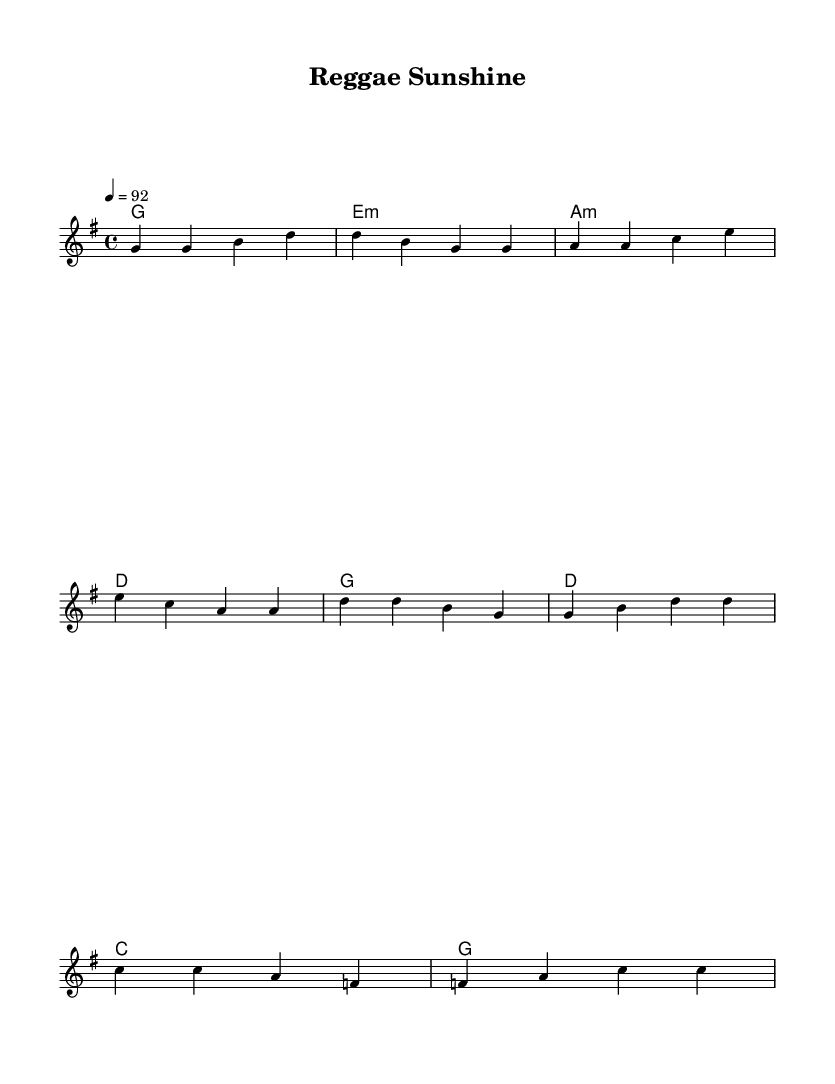What is the key signature of this music? The key signature is G major, which has one sharp (F#). This is determined by analyzing the key signature section in the sheet music, where it indicates the note functions.
Answer: G major What is the time signature of the piece? The time signature is 4/4, indicating there are four beats in each measure and the quarter note gets one beat. This can be found at the beginning of the score, near the clef and key signature.
Answer: 4/4 What is the tempo marking for this piece? The tempo marking is 92 beats per minute, given as "4 = 92" in the tempo indication. This tells us the speed at which to perform the music.
Answer: 92 How many measures are in the verse section? The verse section includes four measures, as counted from the notation in the music. Each set of bars indicates a measure, and there are four distinct groups for the verse.
Answer: 4 What chords are used in the chorus section? The chords for the chorus section are G, D, C, G. These are explicitly stated in the chord changes above the melody, following the progression laid out in the music.
Answer: G, D, C, G What is a characteristic feature of reggae music reflected in this piece? A characteristic feature of reggae music reflected in this piece is the offbeat rhythm typically played on the guitar or keyboard. This can be inferred from the structure and flow of the melody, emphasizing the laid-back grooves common in reggae.
Answer: Offbeat rhythm How does the harmony in the verse section contribute to the overall feel of the piece? The harmony in the verse section alternates between G major, E minor, A minor, and D major, creating a mellow and relaxed atmosphere typical of reggae. This progression supports the lyrical content while adhering to reggae's signature sound.
Answer: Mellow atmosphere 